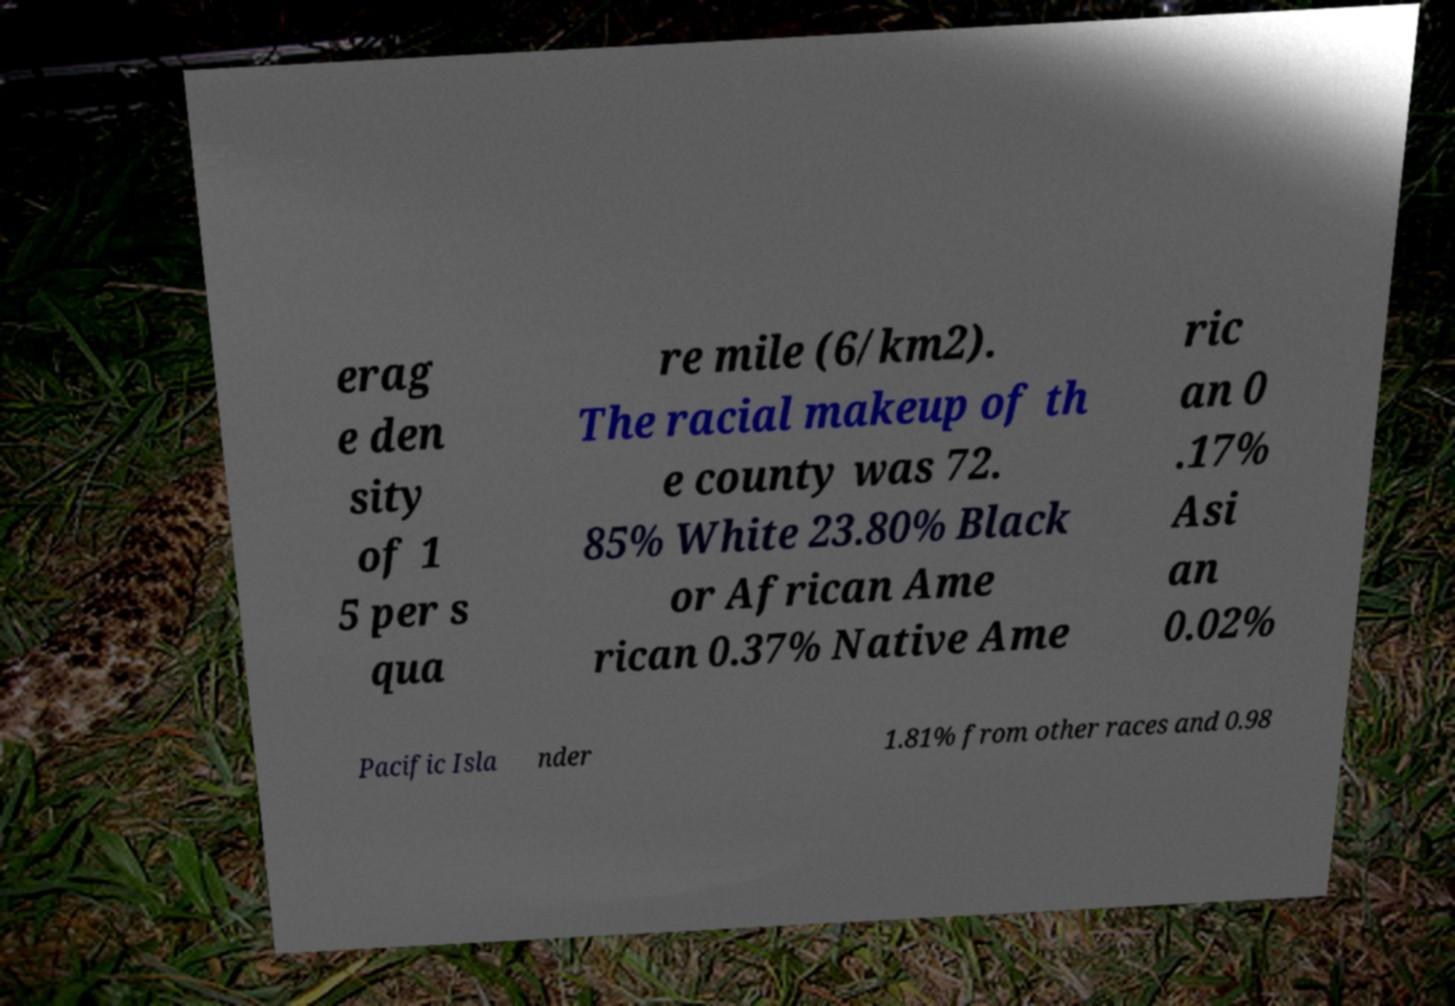There's text embedded in this image that I need extracted. Can you transcribe it verbatim? erag e den sity of 1 5 per s qua re mile (6/km2). The racial makeup of th e county was 72. 85% White 23.80% Black or African Ame rican 0.37% Native Ame ric an 0 .17% Asi an 0.02% Pacific Isla nder 1.81% from other races and 0.98 